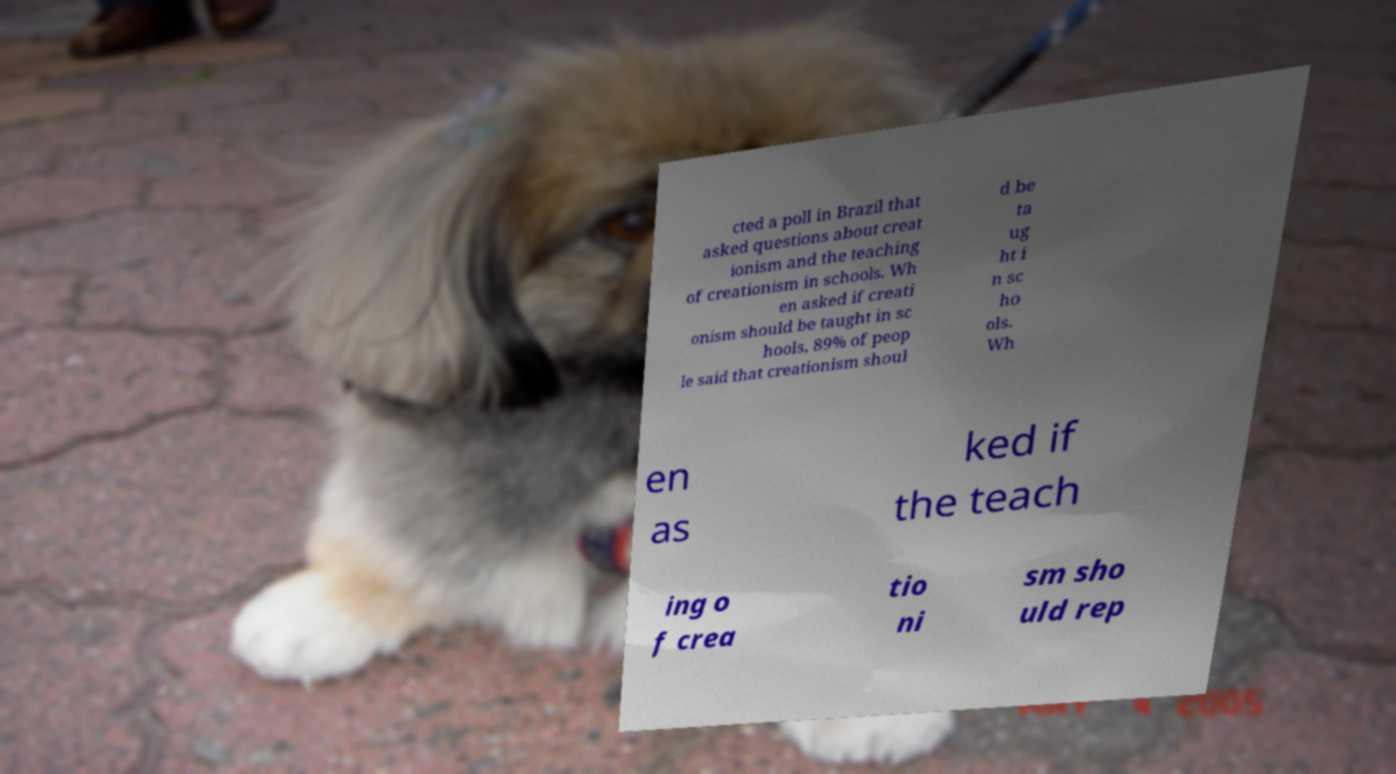What messages or text are displayed in this image? I need them in a readable, typed format. cted a poll in Brazil that asked questions about creat ionism and the teaching of creationism in schools. Wh en asked if creati onism should be taught in sc hools, 89% of peop le said that creationism shoul d be ta ug ht i n sc ho ols. Wh en as ked if the teach ing o f crea tio ni sm sho uld rep 